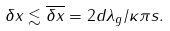<formula> <loc_0><loc_0><loc_500><loc_500>\delta x \lesssim \overline { \delta x } = 2 d \lambda _ { g } / \kappa \pi s .</formula> 